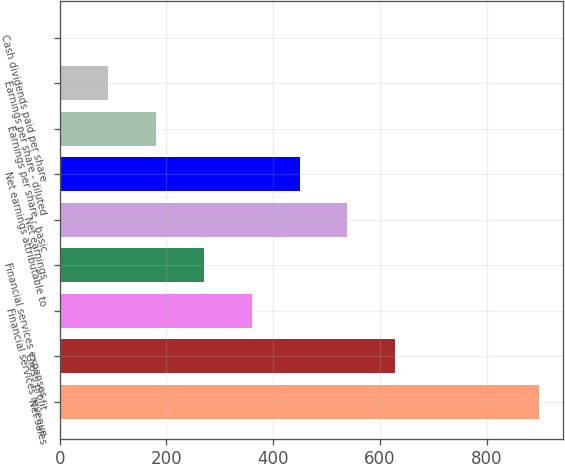Convert chart. <chart><loc_0><loc_0><loc_500><loc_500><bar_chart><fcel>Net sales<fcel>Gross profit<fcel>Financial services revenue<fcel>Financial services expenses<fcel>Net earnings<fcel>Net earnings attributable to<fcel>Earnings per share - basic<fcel>Earnings per share - diluted<fcel>Cash dividends paid per share<nl><fcel>898.1<fcel>628.93<fcel>359.74<fcel>270.01<fcel>539.2<fcel>449.47<fcel>180.28<fcel>90.55<fcel>0.82<nl></chart> 